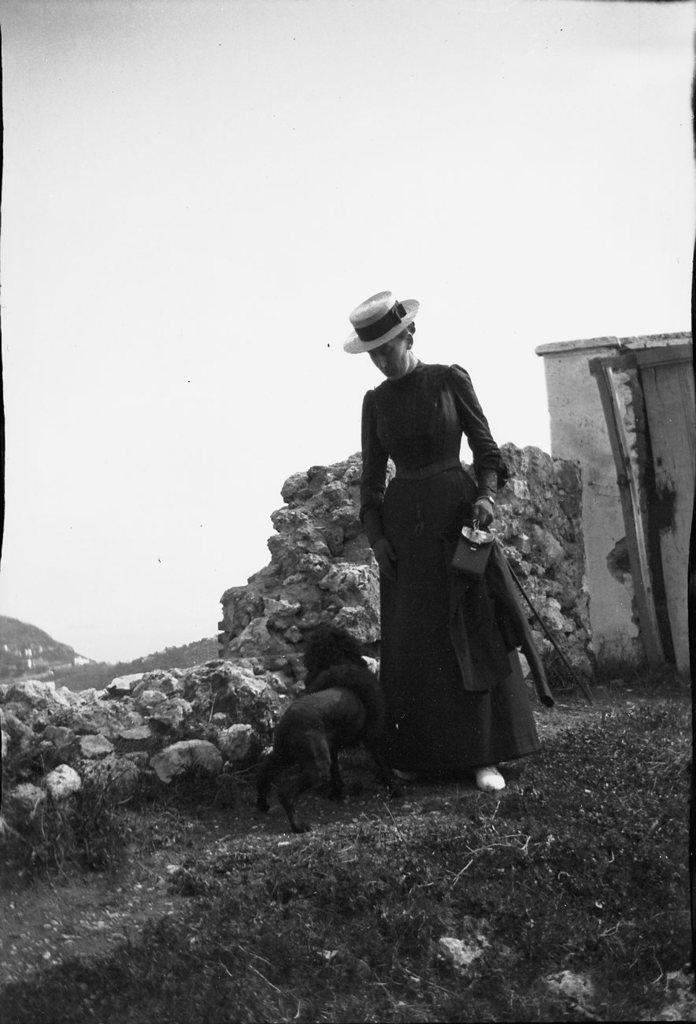What is the color scheme of the image? The image is black and white. What can be seen in the front of the image? There are rocks, an animal, a wall, and a woman in the front of the image. What is the woman holding in the image? The woman is holding objects in the image. What is visible in the background of the image? There is a sky visible in the background of the image. How many passengers are visible in the image? There are no passengers present in the image. What type of quilt is being used by the animal in the image? There is no quilt present in the image, and the animal is not using any object. What is the woman eating for breakfast in the image? There is no food, such as oatmeal, visible in the image. 